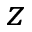Convert formula to latex. <formula><loc_0><loc_0><loc_500><loc_500>z</formula> 